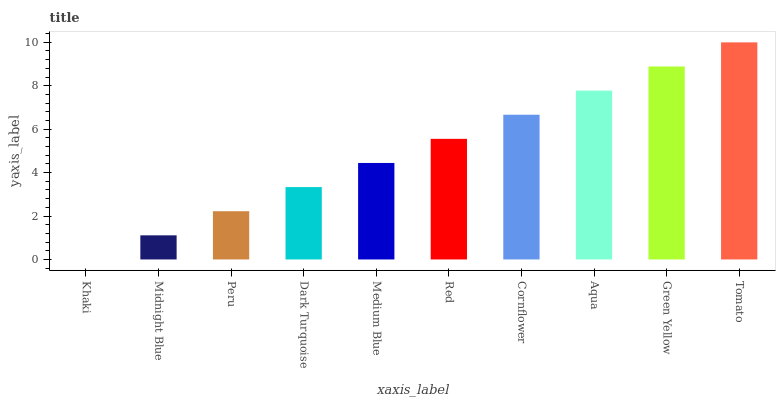Is Khaki the minimum?
Answer yes or no. Yes. Is Tomato the maximum?
Answer yes or no. Yes. Is Midnight Blue the minimum?
Answer yes or no. No. Is Midnight Blue the maximum?
Answer yes or no. No. Is Midnight Blue greater than Khaki?
Answer yes or no. Yes. Is Khaki less than Midnight Blue?
Answer yes or no. Yes. Is Khaki greater than Midnight Blue?
Answer yes or no. No. Is Midnight Blue less than Khaki?
Answer yes or no. No. Is Red the high median?
Answer yes or no. Yes. Is Medium Blue the low median?
Answer yes or no. Yes. Is Khaki the high median?
Answer yes or no. No. Is Aqua the low median?
Answer yes or no. No. 